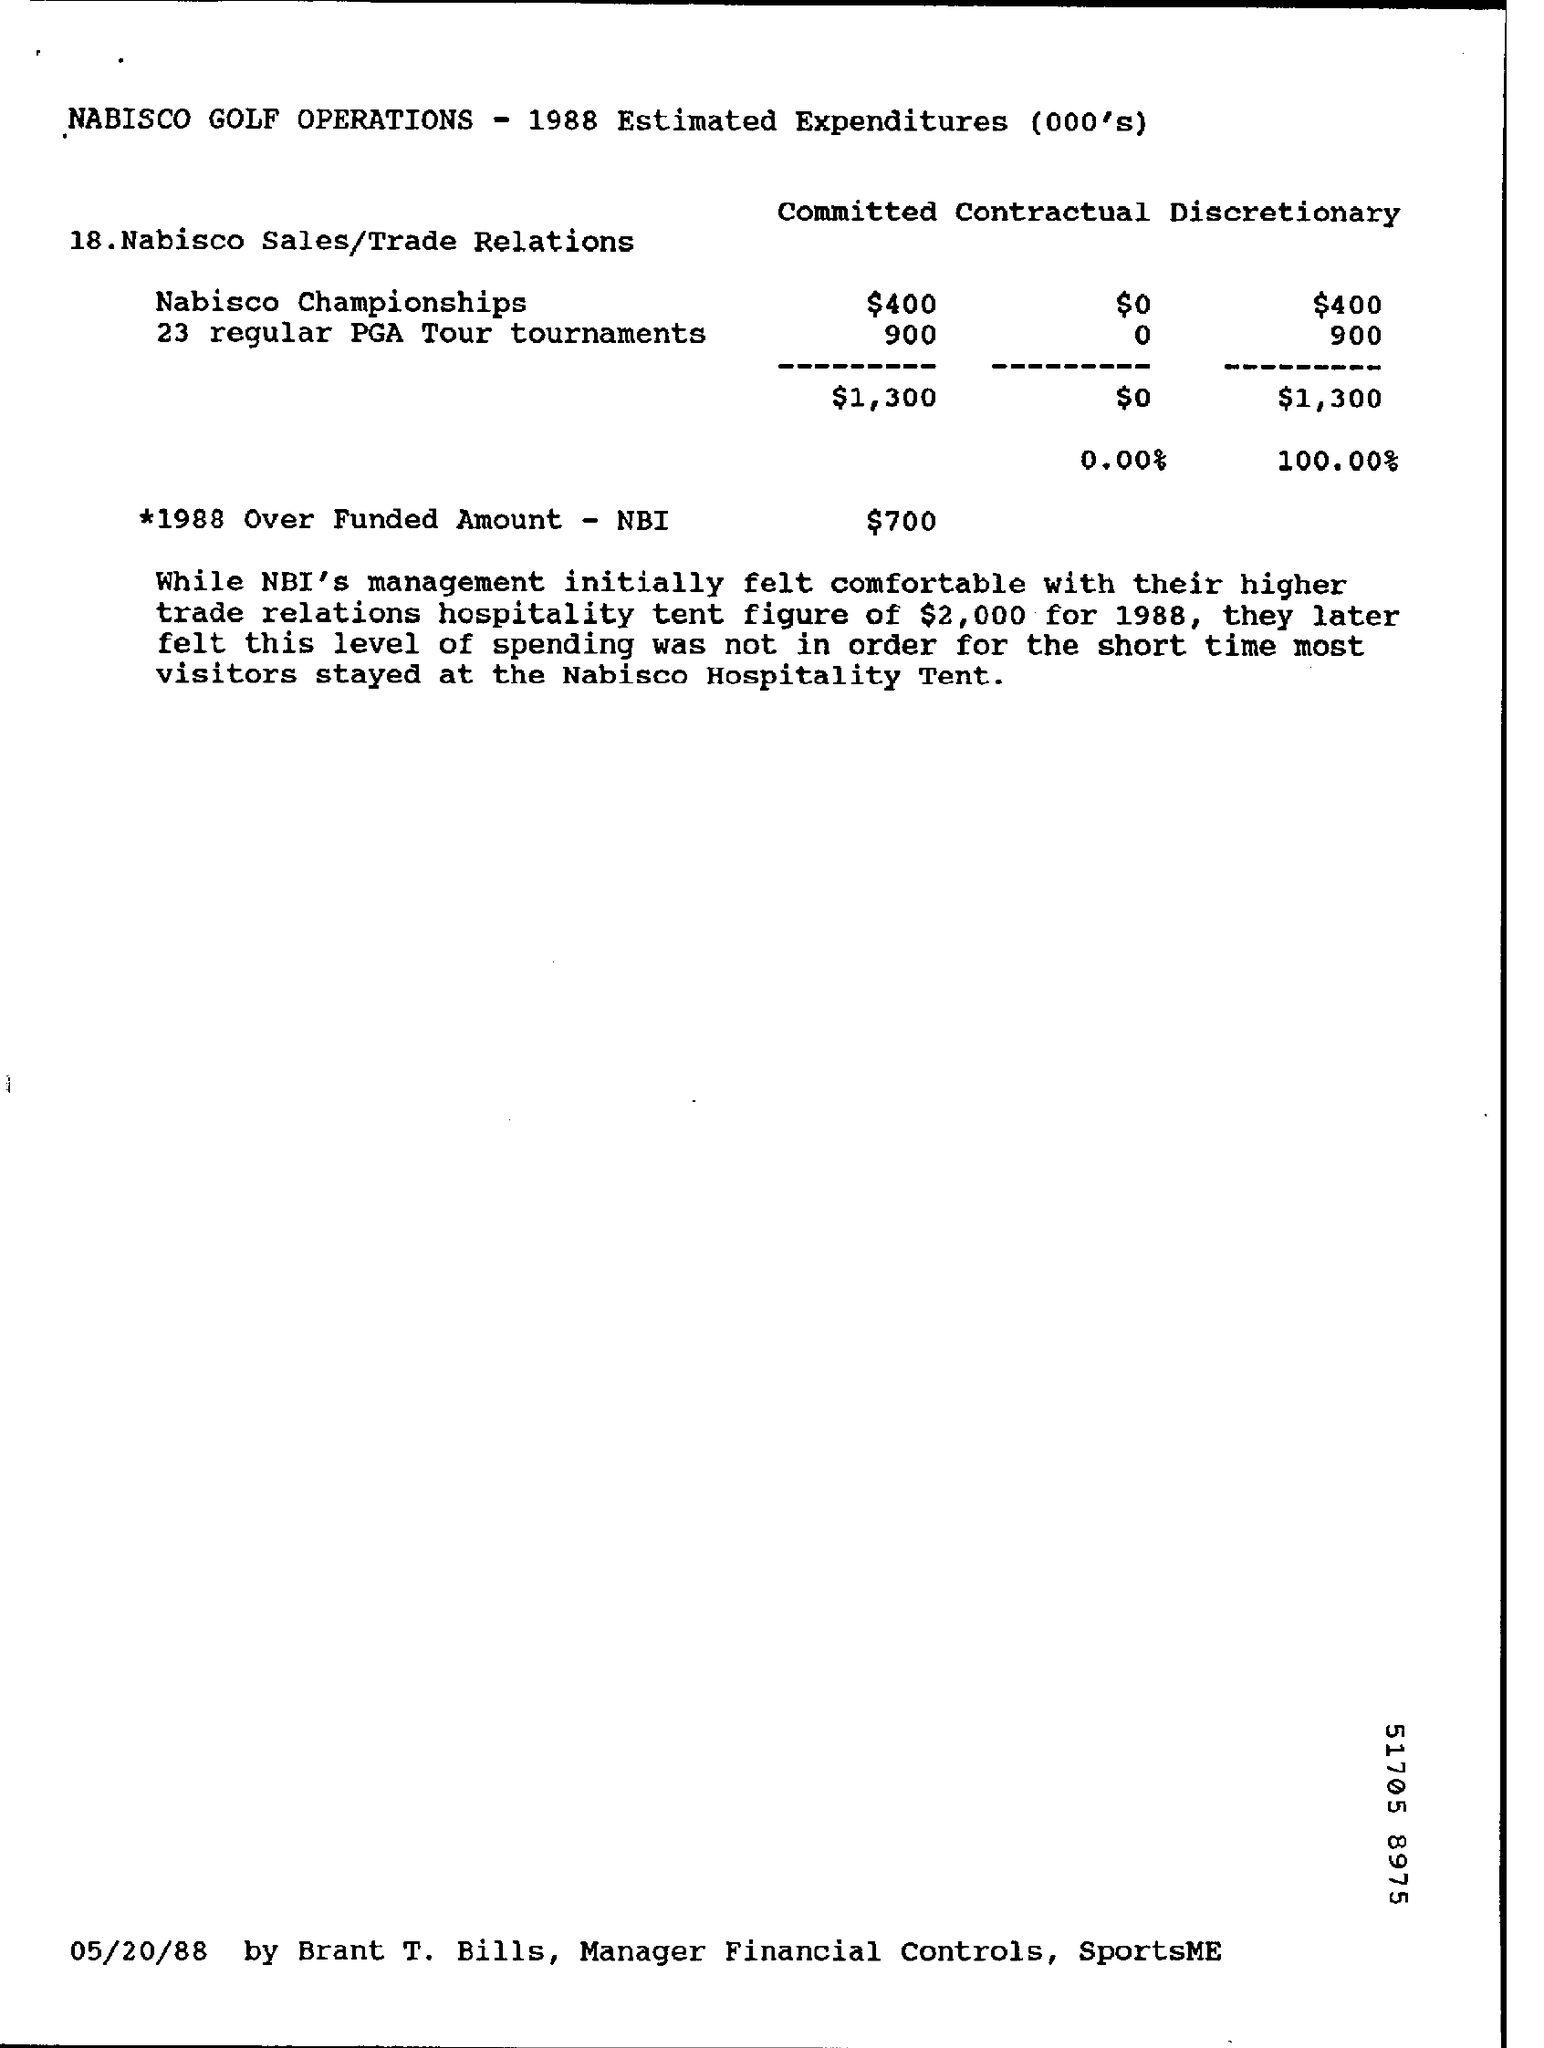Outline some significant characteristics in this image. It is estimated that the expenditure for the Nabisco Championships will be approximately $400. The estimated expenditure of total committed in Nabisco sales and trade relations is $1,300. The overfunded amount, minus the NBI for the year 1988, was $700. According to the estimated expenditure of total discretionary in Nabisco sales and trade relations, the figure is approximately $1,300. 